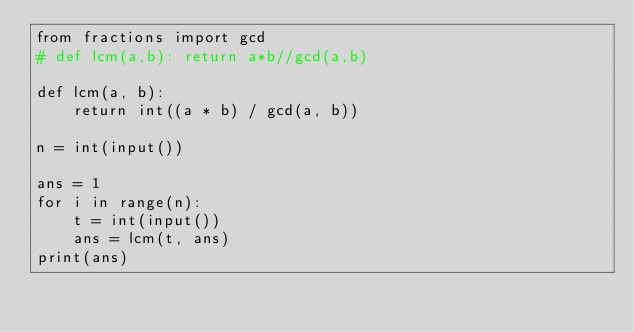Convert code to text. <code><loc_0><loc_0><loc_500><loc_500><_Python_>from fractions import gcd
# def lcm(a,b): return a*b//gcd(a,b)

def lcm(a, b):
    return int((a * b) / gcd(a, b))

n = int(input())

ans = 1
for i in range(n):
    t = int(input())
    ans = lcm(t, ans)
print(ans)</code> 